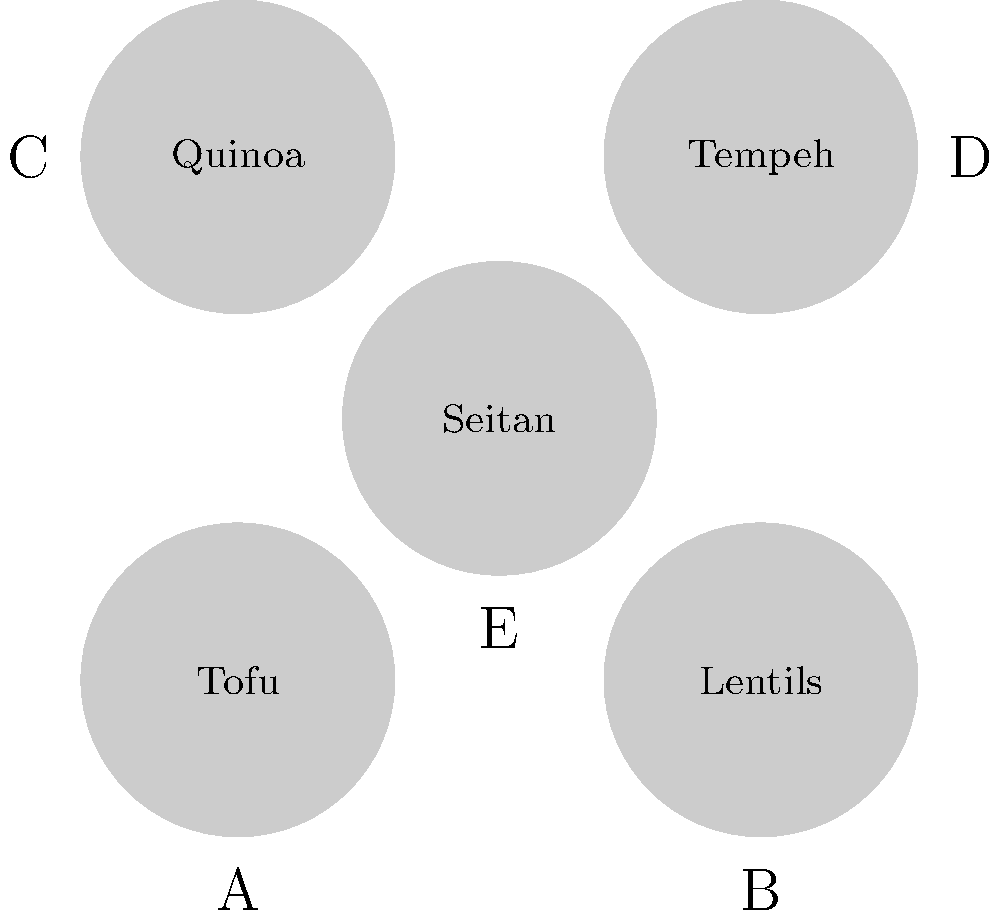Identify the food item that contains the highest amount of protein per 100 grams from the plant-based options shown in the image. To determine which food item has the highest protein content per 100 grams, let's analyze each option:

1. Tofu: Contains about 8-15 grams of protein per 100 grams.
2. Lentils: Provide approximately 9 grams of protein per 100 grams (cooked).
3. Quinoa: Offers about 4-5 grams of protein per 100 grams (cooked).
4. Tempeh: Contains roughly 19-20 grams of protein per 100 grams.
5. Seitan: Provides approximately 25-30 grams of protein per 100 grams.

Comparing these values, we can see that seitan has the highest protein content per 100 grams among the options presented.
Answer: Seitan 